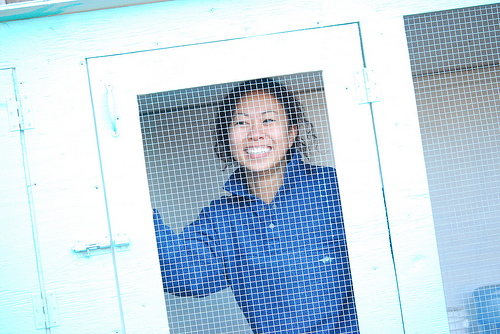<image>
Can you confirm if the square is in front of the woman? Yes. The square is positioned in front of the woman, appearing closer to the camera viewpoint. Is there a woman in front of the door? No. The woman is not in front of the door. The spatial positioning shows a different relationship between these objects. 